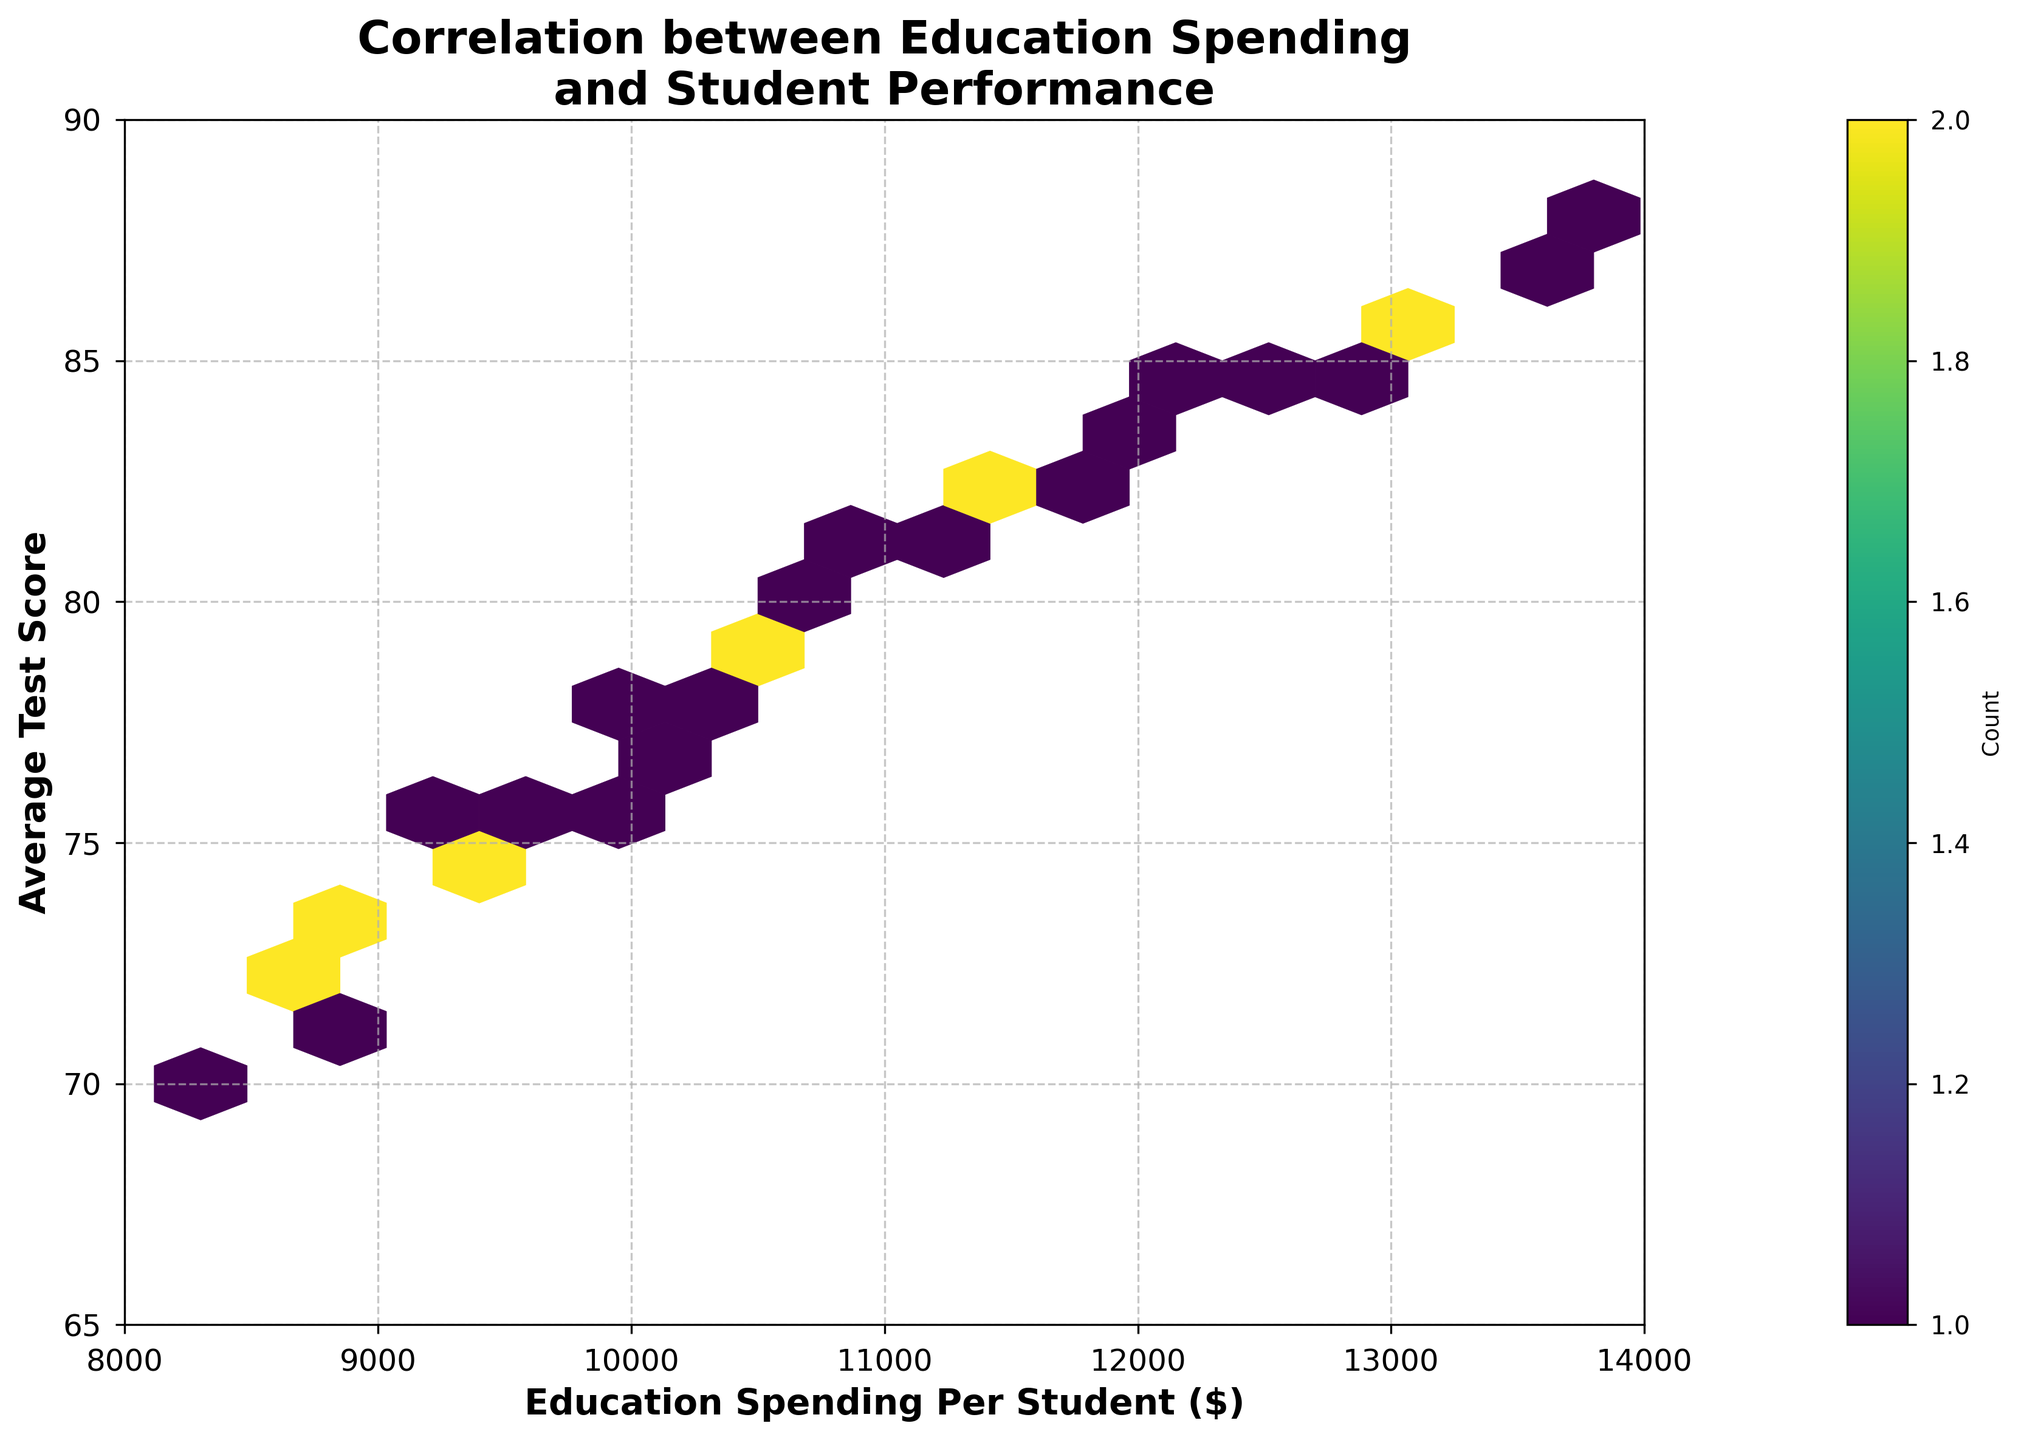What is the title of the hexbin plot? The title is at the top of the hexbin plot and summarizes what the plot is about. The title reads "Correlation between Education Spending and Student Performance."
Answer: Correlation between Education Spending and Student Performance What does the color bar represent in the hexbin plot? The color bar, located next to the plot, indicates the count or frequency of data points within each hexbin. The label "Count" further clarifies this.
Answer: Count What is the range of the x-axis on the hexbin plot? The x-axis represents Education Spending Per Student and is labeled as such. It ranges from $8,000 to $14,000.
Answer: 8000 to 14000 What is the range of the y-axis on the hexbin plot? The y-axis represents the Average Test Score and is labeled accordingly. It ranges from 65 to 90.
Answer: 65 to 90 Which range of education spending per student has the most frequent data points? By looking at the color intensity on the hexbin plot, we can determine where the most data points are clustered. The color is most intense around the spending range of $10,000 to $12,000.
Answer: 10000 to 12000 How is the correlation between education spending per student and average test scores depicted in the hexbin plot? The general trend of the hexagons moving upwards to the right indicates a positive correlation between education spending per student and average test scores. This means higher spending is associated with higher student performance.
Answer: Positive correlation Are there any gaps or sparsely populated areas in the hexbin plot? By examining the plot, we see that there are fewer data points in regions corresponding to higher spending (above $13,200) and low average test scores (below 70). Sparse areas can be identified by the lighter colors or absence of hexagons.
Answer: Yes What does the color gradient from light to dark signify in the hexbin plot? The color gradient, changing from light to dark, indicates the density of data points within each hexbin. Darker colors signify higher density or count of data points, while lighter colors mean lower density.
Answer: Density of data points What can be inferred about student performance scores for districts with very low education spending (below $8,500)? Observing the hexbin plot, districts with education spending below $8,500 tend to have average test scores on the lower side, typically below 75, as shown by the clustering of hexagons.
Answer: Lower scores, typically below 75 